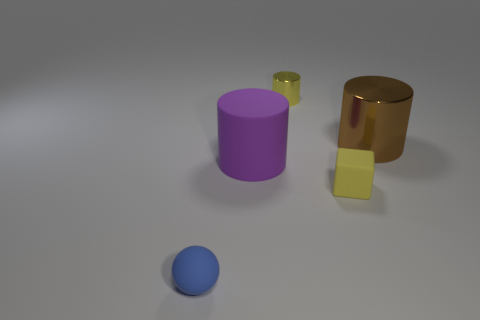Subtract all yellow cylinders. How many cylinders are left? 2 Subtract 0 purple spheres. How many objects are left? 5 Subtract all spheres. How many objects are left? 4 Subtract 1 cubes. How many cubes are left? 0 Subtract all purple cylinders. Subtract all brown cubes. How many cylinders are left? 2 Subtract all gray blocks. How many purple cylinders are left? 1 Subtract all small yellow cubes. Subtract all purple objects. How many objects are left? 3 Add 3 big purple things. How many big purple things are left? 4 Add 4 cylinders. How many cylinders exist? 7 Add 5 tiny metal objects. How many objects exist? 10 